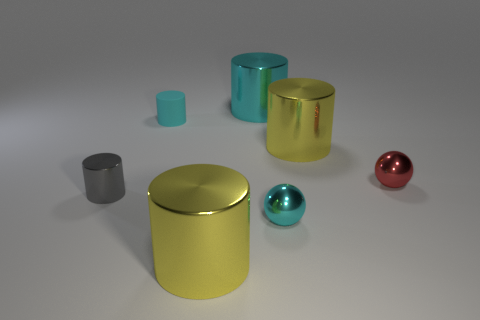Subtract 1 cylinders. How many cylinders are left? 4 Subtract all purple cylinders. Subtract all cyan balls. How many cylinders are left? 5 Add 3 tiny cyan shiny objects. How many objects exist? 10 Subtract all spheres. How many objects are left? 5 Subtract 0 red cubes. How many objects are left? 7 Subtract all red shiny cylinders. Subtract all balls. How many objects are left? 5 Add 2 cyan shiny things. How many cyan shiny things are left? 4 Add 7 cyan rubber cylinders. How many cyan rubber cylinders exist? 8 